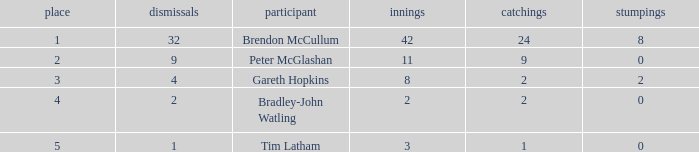How many dismissals did the player Peter McGlashan have? 9.0. 